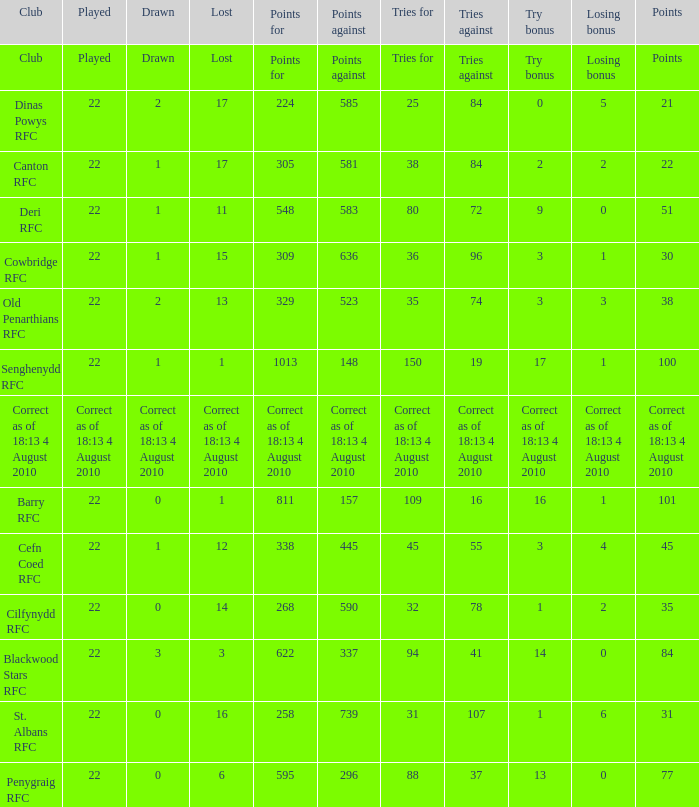What is the name of the club when the played number is 22, and the try bonus was 0? Dinas Powys RFC. 